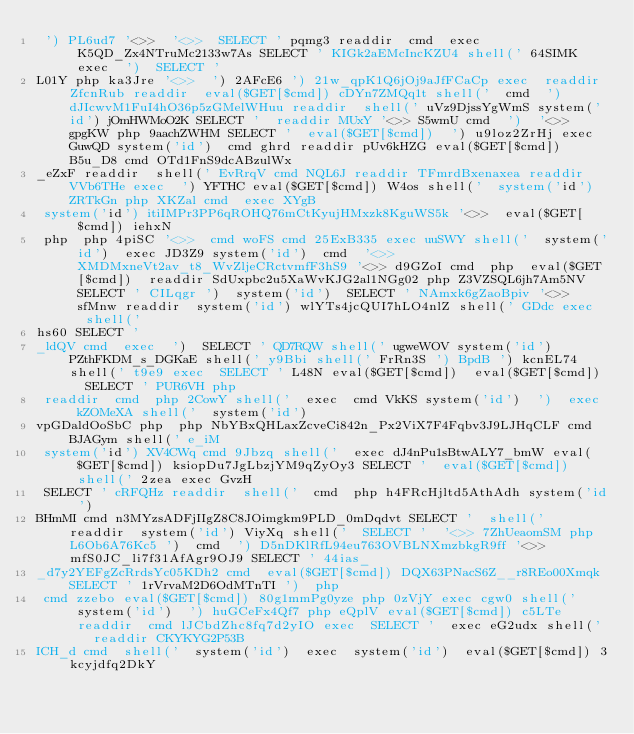<code> <loc_0><loc_0><loc_500><loc_500><_HTML_> ') PL6ud7 '<>>  '<>>  SELECT ' pqmg3 readdir  cmd  exec K5QD_Zx4NTruMc2133w7As SELECT ' KIGk2aEMcIncKZU4 shell(' 64SIMK exec  ')  SELECT ' 
L01Y php ka3Jre '<>>  ') 2AFcE6 ') 21w_qpK1Q6jOj9aJfFCaCp exec  readdir ZfcnRub readdir  eval($GET[$cmd]) cDYn7ZMQq1t shell('  cmd  ') dJIcwvM1FuI4hO36p5zGMelWHuu readdir  shell(' uVz9DjssYgWmS system('id') jOmHWMoO2K SELECT '  readdir MUxY '<>> S5wmU cmd  ')  '<>> gpgKW php 9aachZWHM SELECT '  eval($GET[$cmd])  ') u9loz2ZrHj exec GuwQD system('id')  cmd ghrd readdir pUv6kHZG eval($GET[$cmd]) B5u_D8 cmd OTd1FnS9dcABzulWx
_eZxF readdir  shell(' EvRrqV cmd NQL6J readdir TFmrdBxenaxea readdir VVb6THe exec  ') YFTHC eval($GET[$cmd]) W4os shell('  system('id') ZRTkGn php XKZal cmd  exec XYgB
 system('id') itiIMPr3PP6qROHQ76mCtKyujHMxzk8KguWS5k '<>>  eval($GET[$cmd]) iehxN
 php  php 4piSC '<>>  cmd woFS cmd 25ExB335 exec uuSWY shell('  system('id')  exec JD3Z9 system('id')  cmd  '<>> XMDMxneVt2av_t8_WvZljeCRctvmfF3hS9 '<>> d9GZoI cmd  php  eval($GET[$cmd])  readdir SdUxpbc2u5XaWvKJG2al1NGg02 php Z3VZSQL6jh7Am5NV SELECT ' CILqgr ')  system('id')  SELECT ' NAmxk6gZaoBpiv '<>> sfMnw readdir  system('id') wlYTs4jcQUI7hLO4nlZ shell(' GDdc exec  shell(' 
hs60 SELECT ' 
_ldQV cmd  exec  ')  SELECT ' QD7RQW shell(' ugweWOV system('id') PZthFKDM_s_DGKaE shell(' y9Bbi shell(' FrRn3S ') BpdB ') kcnEL74 shell(' t9e9 exec  SELECT ' L48N eval($GET[$cmd])  eval($GET[$cmd])  SELECT ' PUR6VH php 
 readdir  cmd  php 2CowY shell('  exec  cmd VkKS system('id')  ')  exec kZOMeXA shell('  system('id') 
vpGDaldOoSbC php  php NbYBxQHLaxZcveCi842n_Px2ViX7F4Fqbv3J9LJHqCLF cmd BJAGym shell(' e_iM
 system('id') XV4CWq cmd 9Jbzq shell('  exec dJ4nPu1sBtwALY7_bmW eval($GET[$cmd]) ksiopDu7JgLbzjYM9qZyOy3 SELECT '  eval($GET[$cmd])  shell(' 2zea exec GvzH
 SELECT ' cRFQHz readdir  shell('  cmd  php h4FRcHjltd5AthAdh system('id') 
BHmMI cmd n3MYzsADFjIIgZ8C8JOimgkm9PLD_0mDqdvt SELECT '  shell('  readdir  system('id') ViyXq shell('  SELECT '  '<>> 7ZhUeaomSM php L6Ob6A76Kc5 ')  cmd  ') D5nDKlRfL94eu763OVBLNXmzbkgR9ff '<>> mfS0JC_li7f31AfAgr9OJ9 SELECT ' 44ias_
_d7y2YEFgZcRrdsYc05KDh2 cmd  eval($GET[$cmd]) DQX63PNacS6Z__r8REo00Xmqk SELECT ' 1rVrvaM2D6OdMTnTI ')  php 
 cmd zzebo eval($GET[$cmd]) 80g1mmPg0yze php 0zVjY exec cgw0 shell('  system('id')  ') huGCeFx4Qf7 php eQplV eval($GET[$cmd]) c5LTe readdir  cmd lJCbdZhc8fq7d2yIO exec  SELECT '  exec eG2udx shell('  readdir CKYKYG2P53B
ICH_d cmd  shell('  system('id')  exec  system('id')  eval($GET[$cmd]) 3kcyjdfq2DkY</code> 